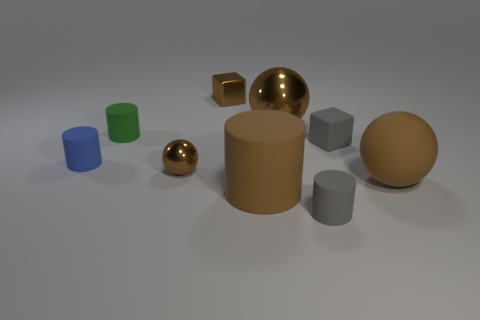Add 1 tiny brown balls. How many objects exist? 10 Subtract all balls. How many objects are left? 6 Add 4 small green shiny cylinders. How many small green shiny cylinders exist? 4 Subtract 1 gray cylinders. How many objects are left? 8 Subtract all large metallic cylinders. Subtract all small gray things. How many objects are left? 7 Add 8 large shiny things. How many large shiny things are left? 9 